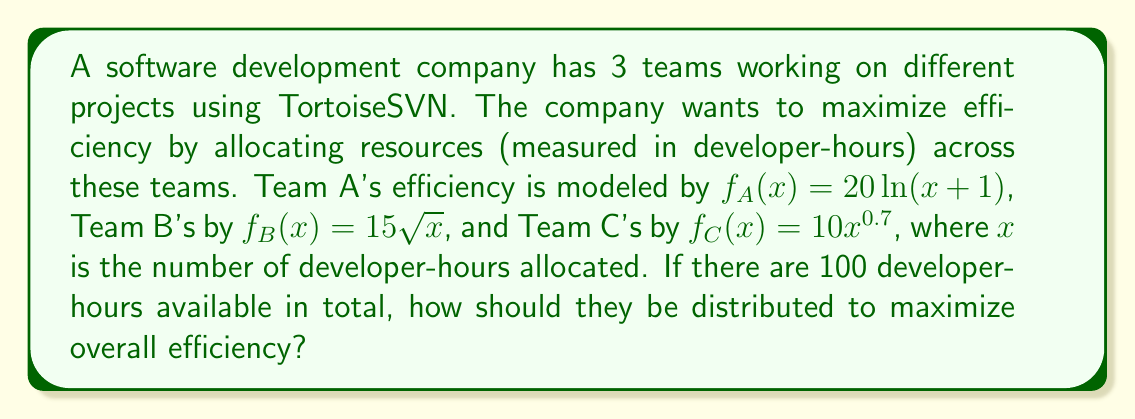Can you solve this math problem? To solve this optimization problem, we'll use the method of Lagrange multipliers:

1) Let $x$, $y$, and $z$ be the developer-hours allocated to Teams A, B, and C respectively.

2) Our objective function is:
   $$f(x,y,z) = 20\ln(x+1) + 15\sqrt{y} + 10z^{0.7}$$

3) The constraint is:
   $$g(x,y,z) = x + y + z - 100 = 0$$

4) Form the Lagrangian:
   $$L(x,y,z,\lambda) = 20\ln(x+1) + 15\sqrt{y} + 10z^{0.7} - \lambda(x + y + z - 100)$$

5) Set partial derivatives to zero:
   $$\frac{\partial L}{\partial x} = \frac{20}{x+1} - \lambda = 0$$
   $$\frac{\partial L}{\partial y} = \frac{15}{2\sqrt{y}} - \lambda = 0$$
   $$\frac{\partial L}{\partial z} = 7z^{-0.3} - \lambda = 0$$
   $$\frac{\partial L}{\partial \lambda} = x + y + z - 100 = 0$$

6) From these equations:
   $$x+1 = \frac{20}{\lambda}$$
   $$y = \frac{225}{4\lambda^2}$$
   $$z = (\frac{7}{\lambda})^{\frac{10}{3}}$$

7) Substitute these into the constraint equation:
   $$\frac{20}{\lambda} - 1 + \frac{225}{4\lambda^2} + (\frac{7}{\lambda})^{\frac{10}{3}} = 100$$

8) This equation can be solved numerically to find $\lambda \approx 0.3947$.

9) Substituting this value back:
   $$x \approx 49.64$$
   $$y \approx 36.18$$
   $$z \approx 14.18$$

10) Rounding to the nearest whole number of developer-hours:
    $x = 50$, $y = 36$, $z = 14$
Answer: Team A should be allocated 50 developer-hours, Team B should be allocated 36 developer-hours, and Team C should be allocated 14 developer-hours to maximize overall efficiency. 